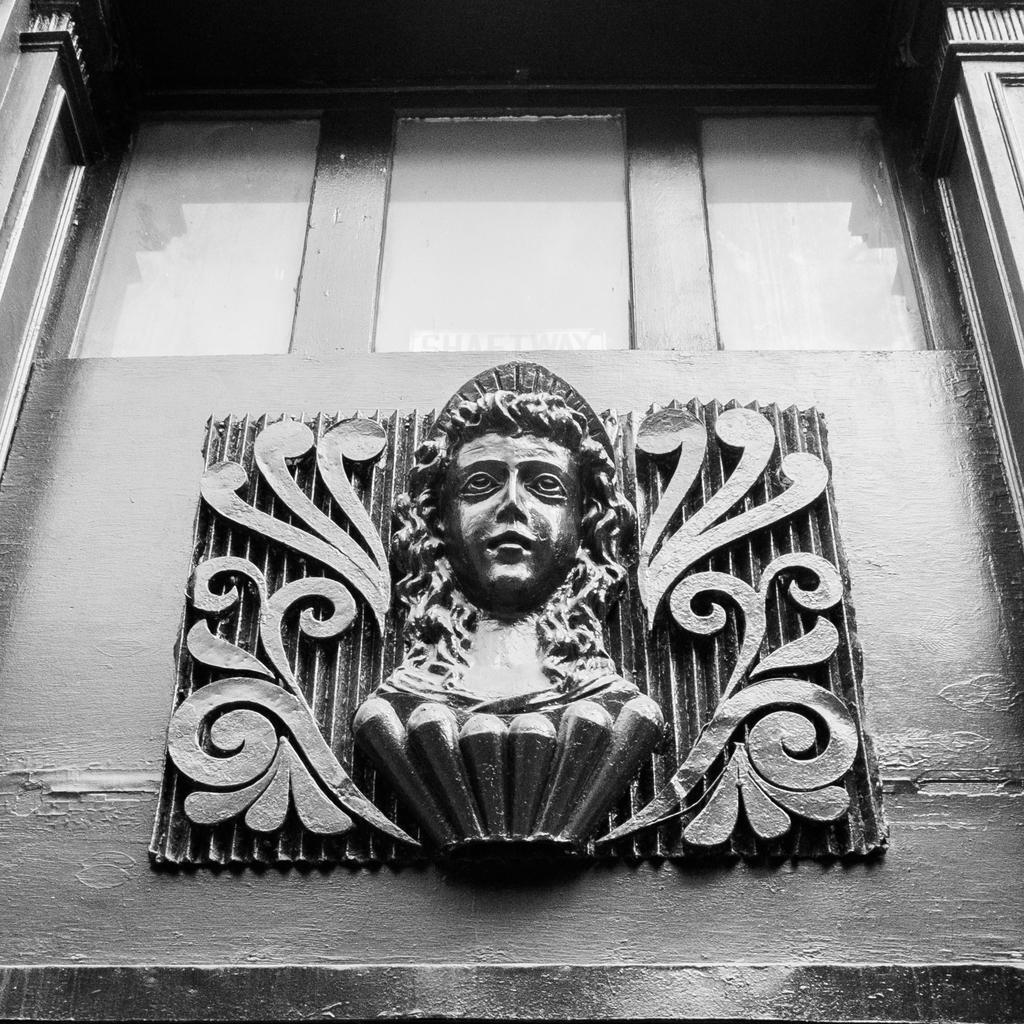In one or two sentences, can you explain what this image depicts? This picture describe about the small face statue attached in the wall. Above we can see glass and wooden Window. 